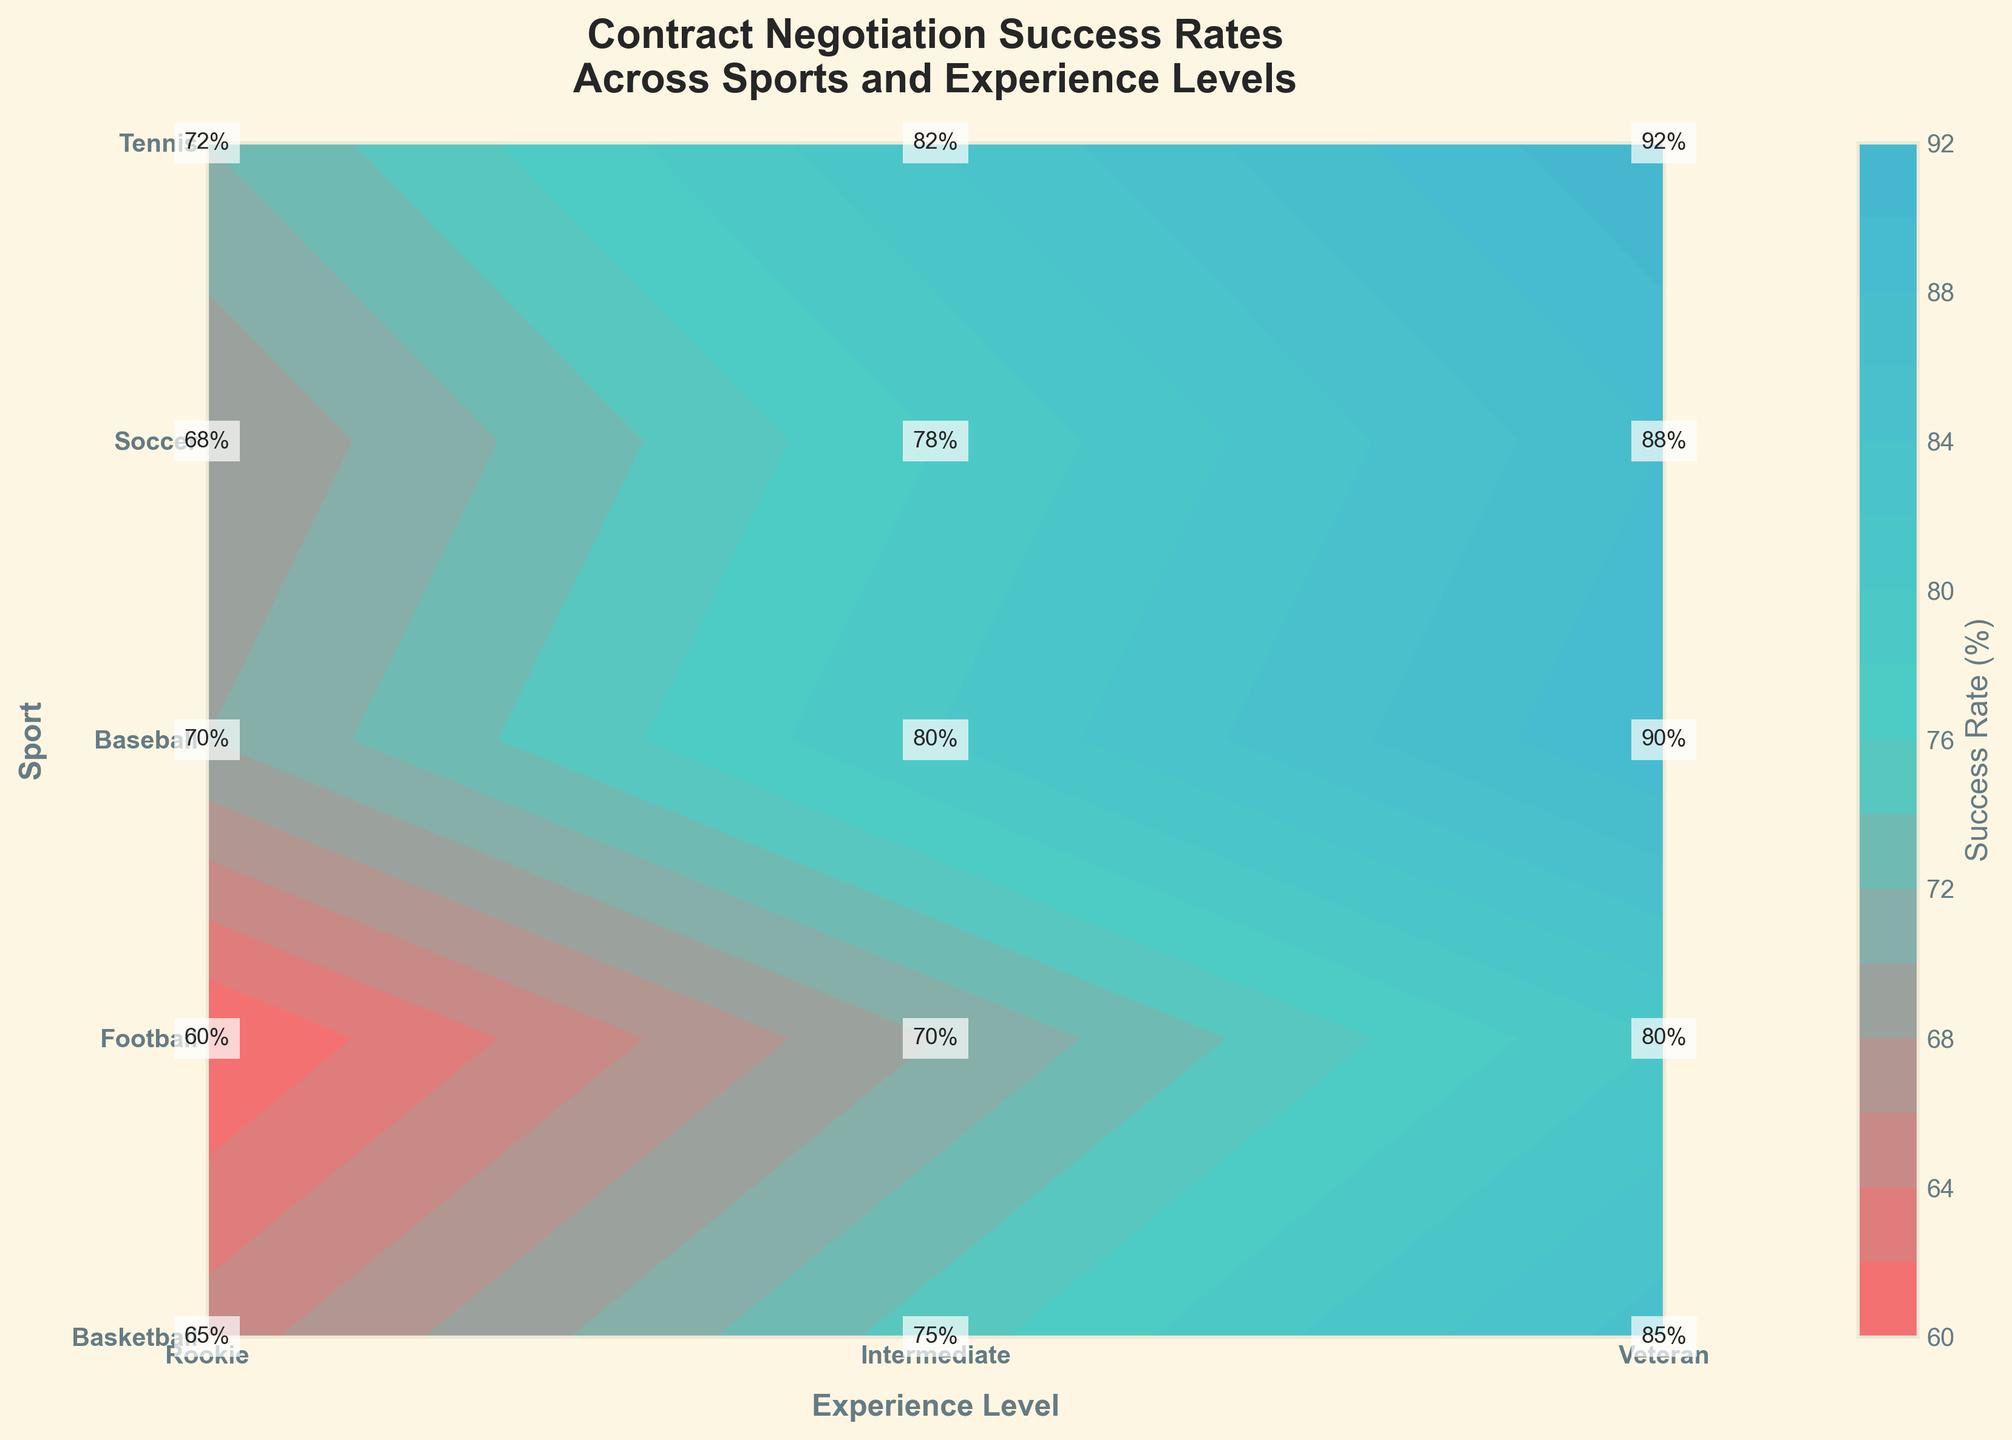What's the title of the figure? The title of the figure is prominently displayed at the top. It reads "Contract Negotiation Success Rates Across Sports and Experience Levels".
Answer: Contract Negotiation Success Rates Across Sports and Experience Levels How many sports are shown in the figure? The y-axis labels list the sports. By counting them, we see that there are five sports listed: Basketball, Football, Baseball, Soccer, and Tennis.
Answer: Five What is the highest success rate for Tennis players? The success rate for Tennis players is labeled at each experience level. The highest success rate, found at the "Veteran" level, is 92%.
Answer: 92% Which sport has the lowest success rate for Rookie players? By comparing the success rates for Rookie players across all sports, Football has the lowest rate marked at 60%.
Answer: Football What's the difference in success rates between Rookie and Veteran Basketball players? The success rates for Basketball players are labeled for each experience level. The difference is calculated as follows: 85% (Veteran) - 65% (Rookie) = 20%.
Answer: 20% Which sport sees the highest increase in success rates from Rookie to Veteran level? To find the sport with the highest increase, we calculate the difference for each sport and compare:
- Basketball: 85% - 65% = 20%
- Football: 80% - 60% = 20%
- Baseball: 90% - 70% = 20%
- Soccer: 88% - 68% = 20%
- Tennis: 92% - 72% = 20%
Every sport sees a 20% increase, so there's actually no single sport with a highest increase alone.
Answer: All sports increase equally How does the success rate for Intermediate Soccer players compare to Intermediate Football players? Looking at the contour labels, Intermediate Soccer players have a success rate of 78% while Intermediate Football players have 70%.
Answer: Soccer players have a higher success rate Which experience level shows the smallest variance in success rates across the sports? To determine the smallest variance, we look at the range of success rates for each experience level:
- Rookie: 60% to 72% (variance 12%)
- Intermediate: 70% to 82% (variance 12%)
- Veteran: 80% to 92% (variance 12%)
Interestingly, all experience levels show the same variance of 12%.
Answer: All levels have equal variance 